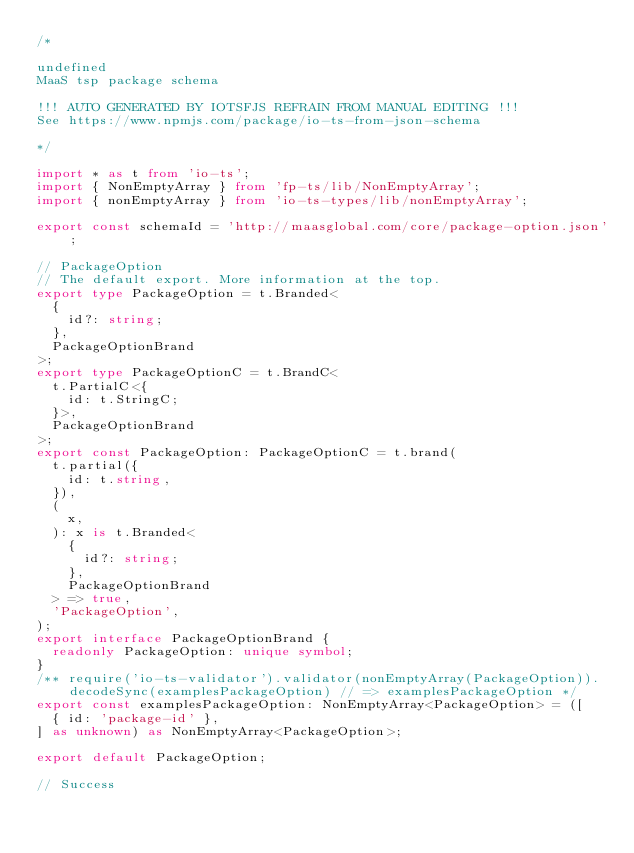<code> <loc_0><loc_0><loc_500><loc_500><_TypeScript_>/*

undefined
MaaS tsp package schema

!!! AUTO GENERATED BY IOTSFJS REFRAIN FROM MANUAL EDITING !!!
See https://www.npmjs.com/package/io-ts-from-json-schema

*/

import * as t from 'io-ts';
import { NonEmptyArray } from 'fp-ts/lib/NonEmptyArray';
import { nonEmptyArray } from 'io-ts-types/lib/nonEmptyArray';

export const schemaId = 'http://maasglobal.com/core/package-option.json';

// PackageOption
// The default export. More information at the top.
export type PackageOption = t.Branded<
  {
    id?: string;
  },
  PackageOptionBrand
>;
export type PackageOptionC = t.BrandC<
  t.PartialC<{
    id: t.StringC;
  }>,
  PackageOptionBrand
>;
export const PackageOption: PackageOptionC = t.brand(
  t.partial({
    id: t.string,
  }),
  (
    x,
  ): x is t.Branded<
    {
      id?: string;
    },
    PackageOptionBrand
  > => true,
  'PackageOption',
);
export interface PackageOptionBrand {
  readonly PackageOption: unique symbol;
}
/** require('io-ts-validator').validator(nonEmptyArray(PackageOption)).decodeSync(examplesPackageOption) // => examplesPackageOption */
export const examplesPackageOption: NonEmptyArray<PackageOption> = ([
  { id: 'package-id' },
] as unknown) as NonEmptyArray<PackageOption>;

export default PackageOption;

// Success
</code> 